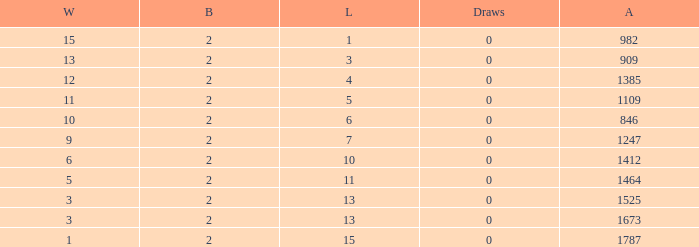What is the highest number listed under against when there were 15 losses and more than 1 win? None. 